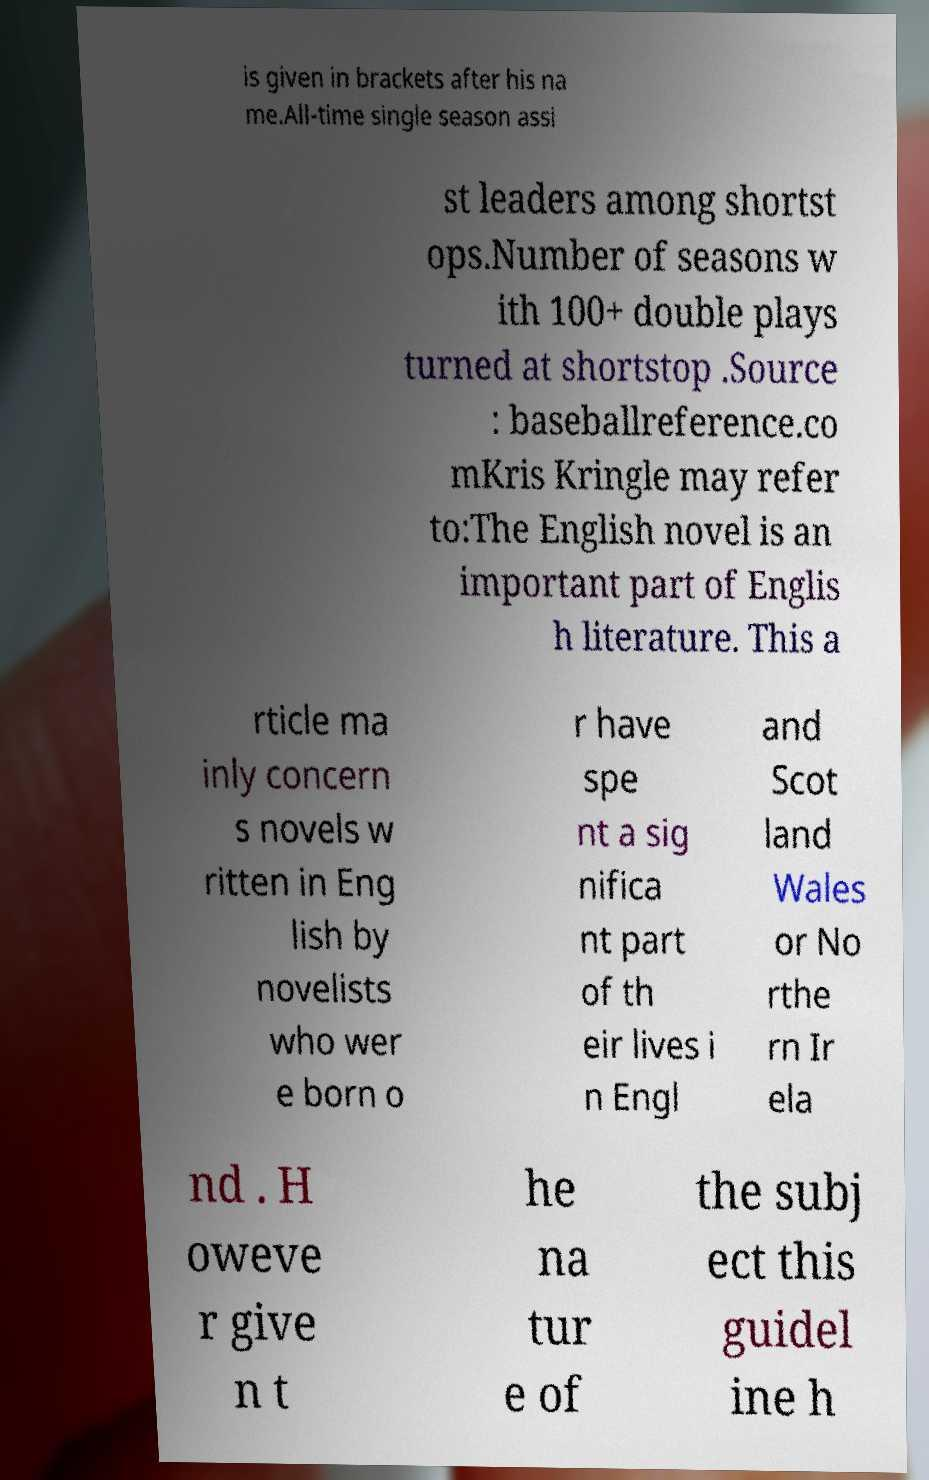There's text embedded in this image that I need extracted. Can you transcribe it verbatim? is given in brackets after his na me.All-time single season assi st leaders among shortst ops.Number of seasons w ith 100+ double plays turned at shortstop .Source : baseballreference.co mKris Kringle may refer to:The English novel is an important part of Englis h literature. This a rticle ma inly concern s novels w ritten in Eng lish by novelists who wer e born o r have spe nt a sig nifica nt part of th eir lives i n Engl and Scot land Wales or No rthe rn Ir ela nd . H oweve r give n t he na tur e of the subj ect this guidel ine h 